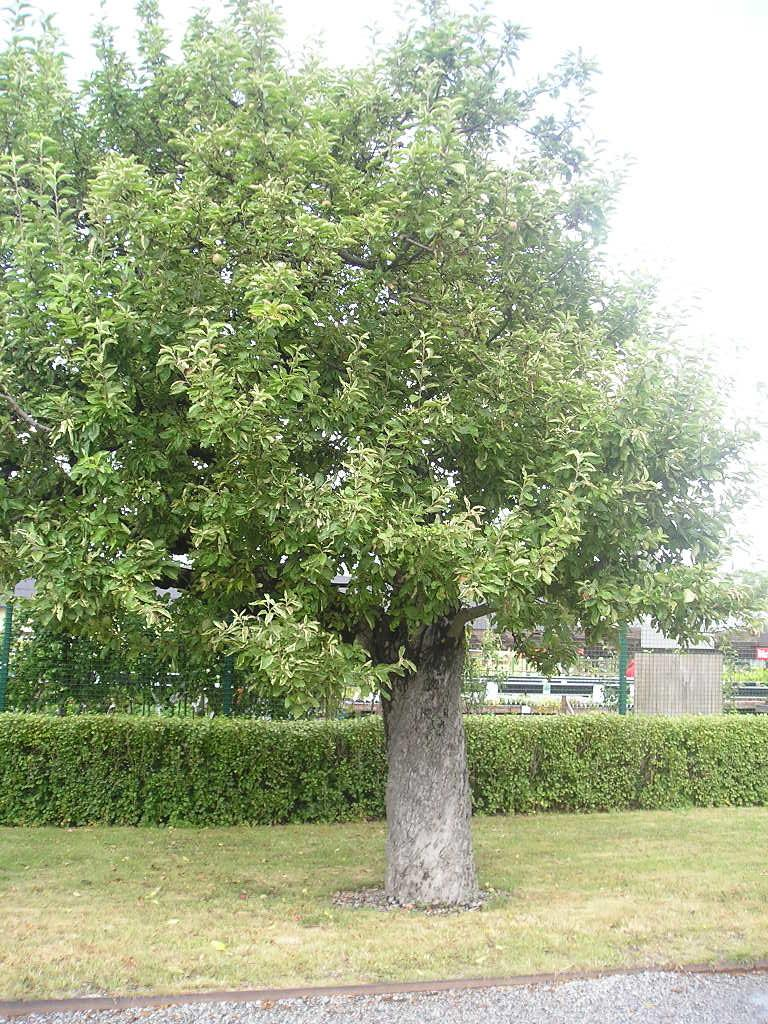What is the main subject in the middle of the picture? There is a tree in the middle of the picture. What can be seen on the ground in the background? There are plants on the ground in the background. What is visible in the background of the picture? The sky is visible in the background. What color is the silver pig eating a banana in the image? There is no silver pig or banana present in the image. 